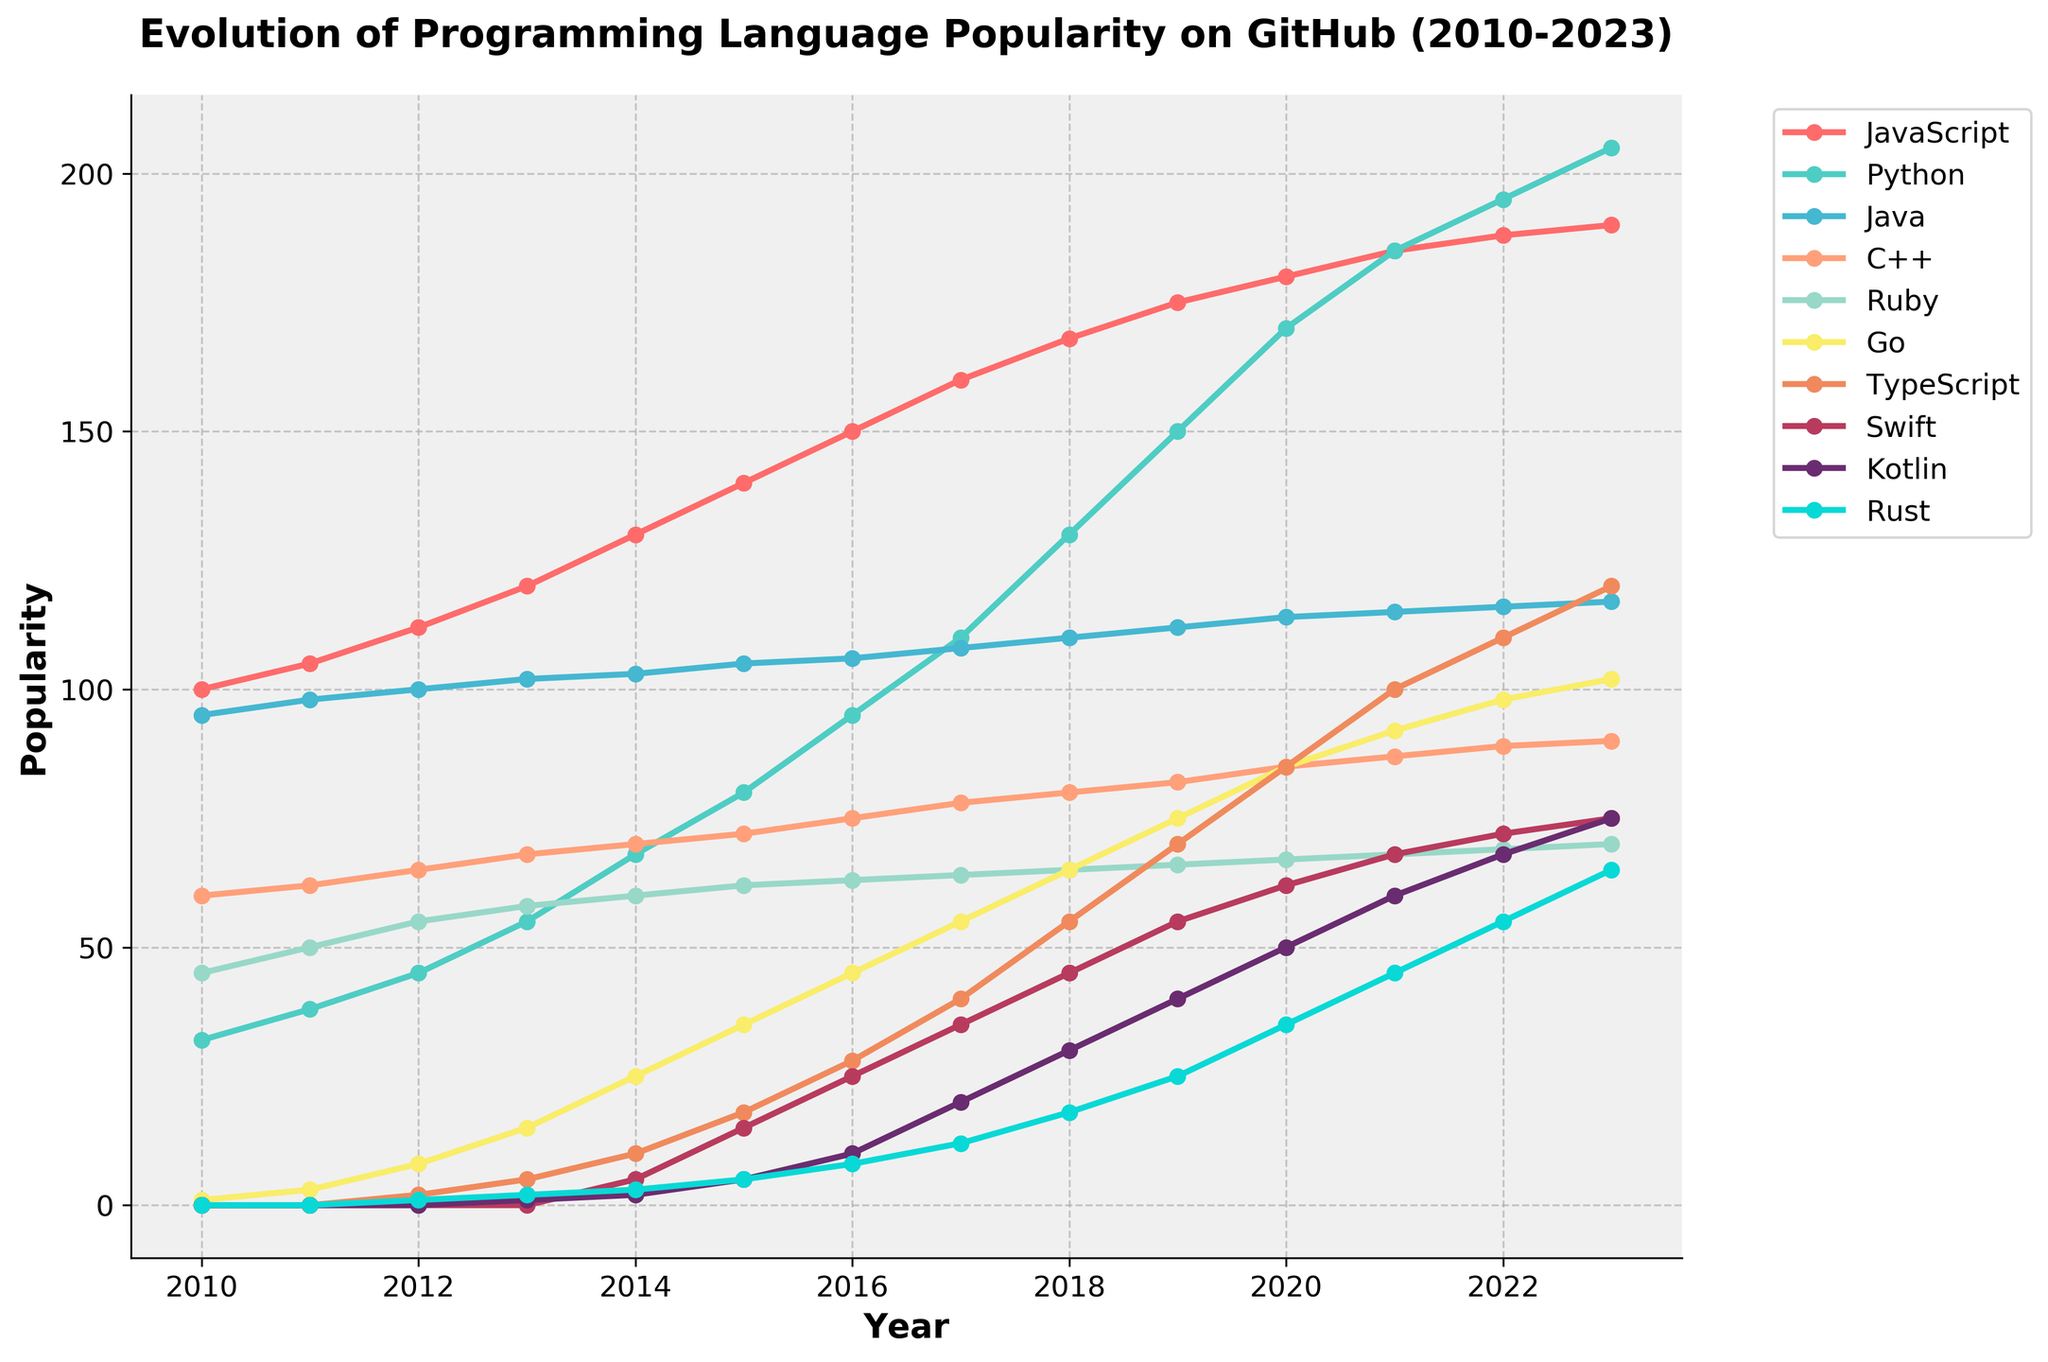Which programming language shows the highest popularity in 2023? To find this, look at the 2023 data points for each language and identify the one with the highest value. JavaScript has the highest value at 190.
Answer: JavaScript Which programming language saw the greatest increase in popularity from 2010 to 2023? Calculate the difference in popularity from 2010 to 2023 for each language. JavaScript increased from 100 to 190, a difference of 90, which is higher than any other language.
Answer: JavaScript What is the average popularity of Python from 2010 to 2023? Add up the popularity values of Python from 2010 to 2023 and then divide by the number of years (14). The sum is 1555, so the average is 1555 / 14 = 111.
Answer: 111 In which year did Go overtake Ruby in terms of popularity? Identify the year where Go's popularity value exceeded Ruby's for the first time. In 2015, Go had a value of 35 while Ruby had 62, and in 2016, Go had a value of 45 while Ruby had 63. Go overtook Ruby in 2019, with values of 75 and 66, respectively.
Answer: 2019 Which language had a decline in popularity from one year to the next? Look for any year-to-year decrease in the popularity values. All languages exhibit a rise in popularity; no language shows a decline between any two consecutive years.
Answer: None How did TypeScript's popularity evolve compared to Kotlin's in 2023? Observe the data points for TypeScript and Kotlin in 2023. TypeScript has a value of 120, while Kotlin has 75. TypeScript is more popular.
Answer: TypeScript What is the difference in popularity between Java and C++ in 2013? Look at the data points for Java and C++ in 2013. Java has a value of 102 and C++ has 68. The difference is 102 - 68 = 34.
Answer: 34 What is the ratio of Python's popularity to JavaScript's popularity in 2021? In 2021, Python has a value of 185 and JavaScript has 185. The ratio is 185/185 which simplifies to 1.
Answer: 1 Which programming language had the least popularity in 2010 and what was its value? Look at the 2010 data points and identify the smallest value. Go has the smallest value with 1.
Answer: Go, 1 How many languages have exceeded 100 in popularity by 2023? Count the number of languages whose popularity values are greater than 100 in the year 2023. JavaScript, Python, Java, TypeScript, Go have values exceeding 100.
Answer: 5 